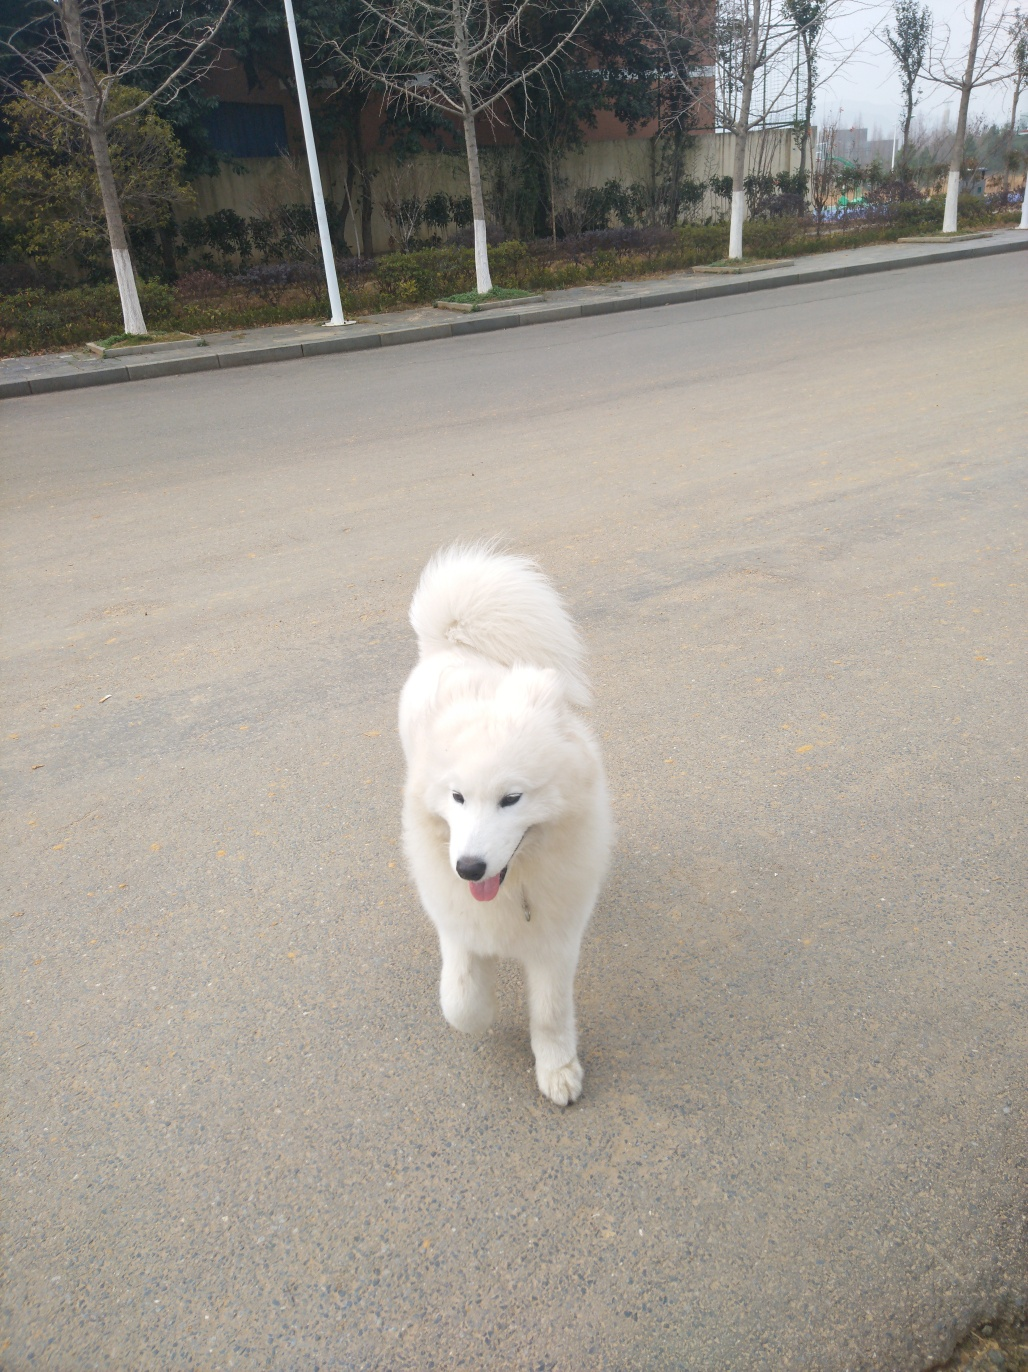What is the color palette like in this image? A. Colorful B. Diverse C. Monotonous D. Vibrant While the image features a snowy white dog which might lead to an initial impression of a 'C. Monotonous' color palette, the background provides a subtle variety of colors including the greys of the road and hints of greenery. Therefore, a more accurate description of the color palette would be 'B. Diverse', acknowledging the presence of different colors and shades, despite a dominance of softer tones. 